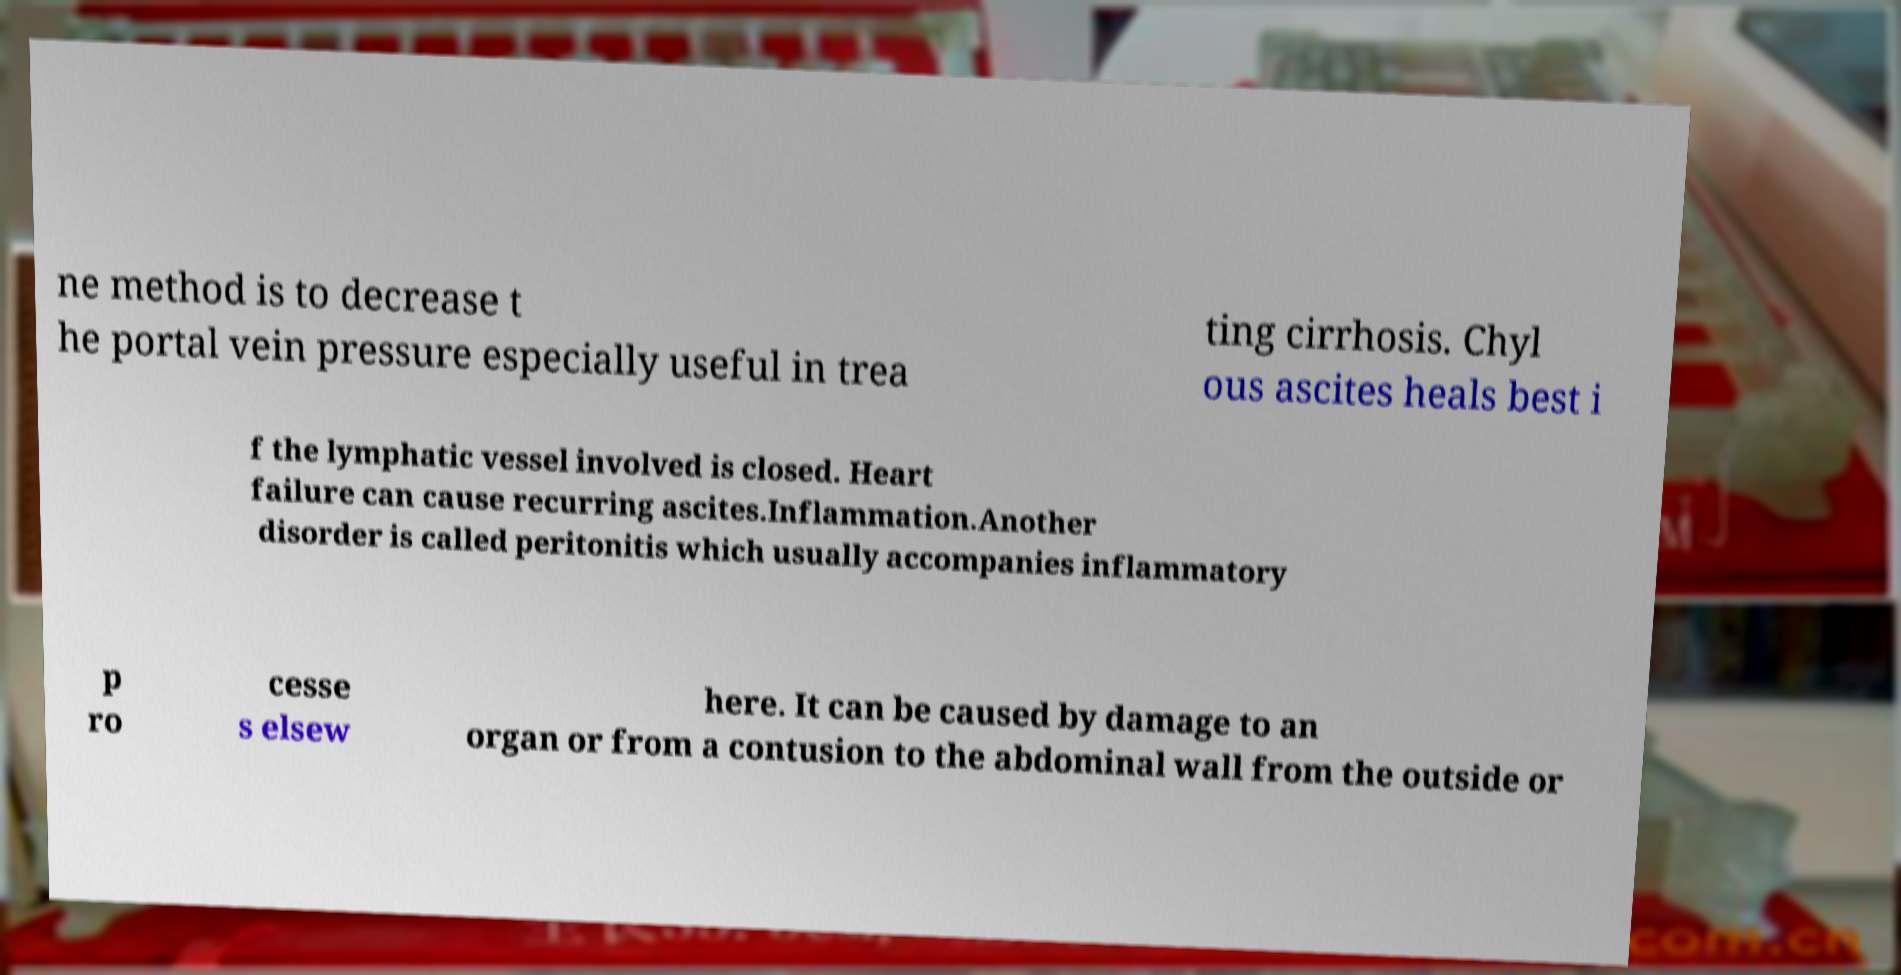I need the written content from this picture converted into text. Can you do that? ne method is to decrease t he portal vein pressure especially useful in trea ting cirrhosis. Chyl ous ascites heals best i f the lymphatic vessel involved is closed. Heart failure can cause recurring ascites.Inflammation.Another disorder is called peritonitis which usually accompanies inflammatory p ro cesse s elsew here. It can be caused by damage to an organ or from a contusion to the abdominal wall from the outside or 